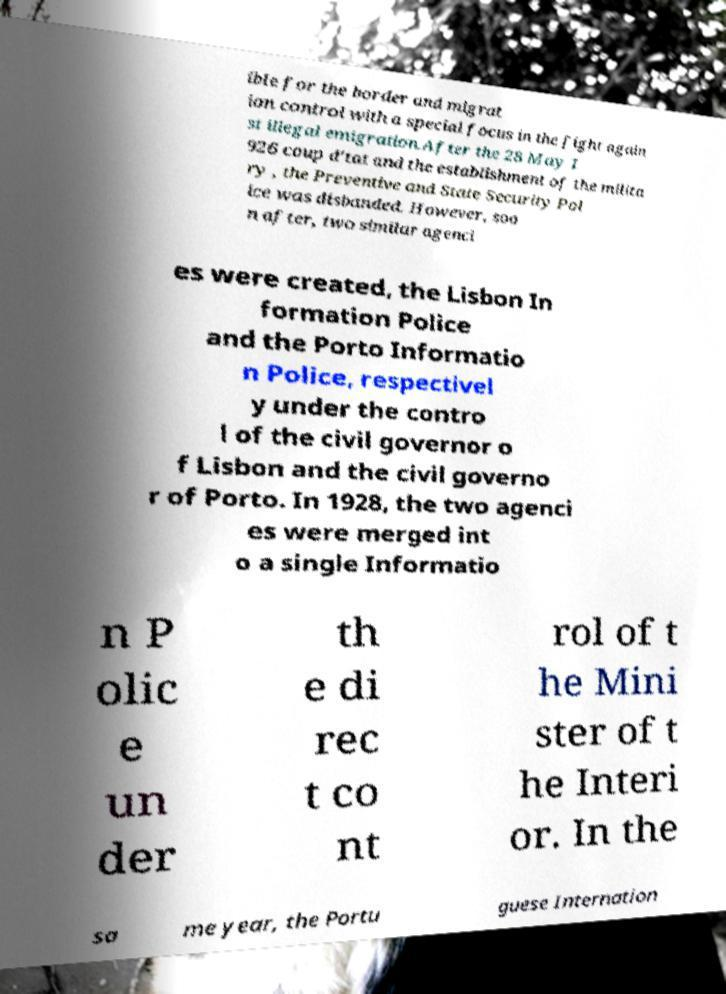Please read and relay the text visible in this image. What does it say? ible for the border and migrat ion control with a special focus in the fight again st illegal emigration.After the 28 May 1 926 coup d'tat and the establishment of the milita ry , the Preventive and State Security Pol ice was disbanded. However, soo n after, two similar agenci es were created, the Lisbon In formation Police and the Porto Informatio n Police, respectivel y under the contro l of the civil governor o f Lisbon and the civil governo r of Porto. In 1928, the two agenci es were merged int o a single Informatio n P olic e un der th e di rec t co nt rol of t he Mini ster of t he Interi or. In the sa me year, the Portu guese Internation 